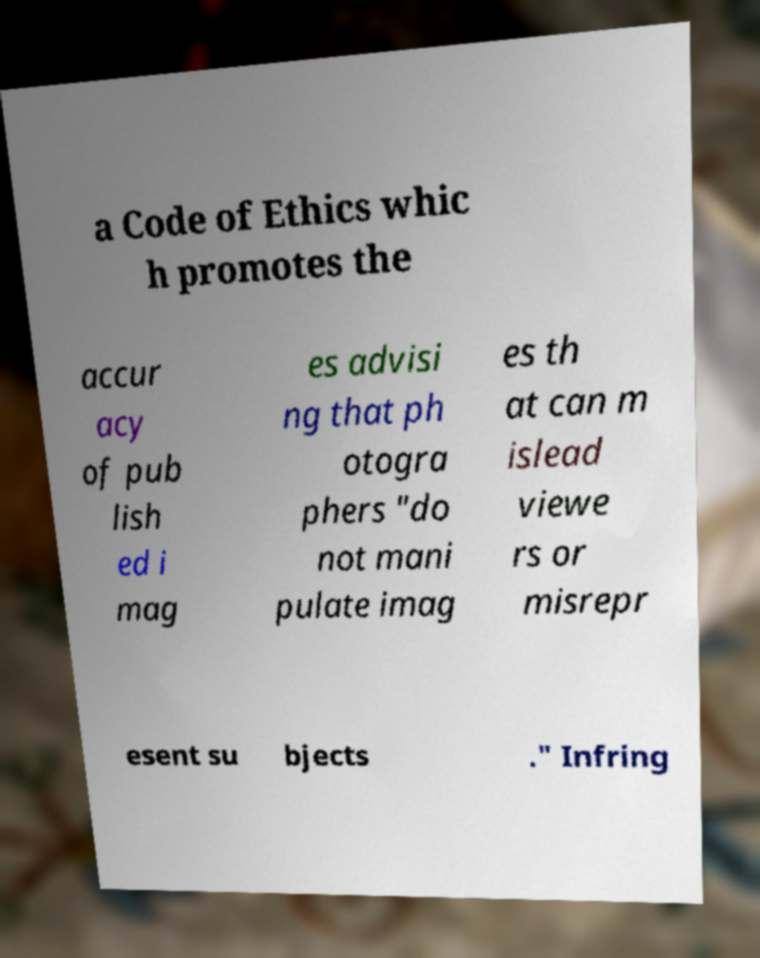What messages or text are displayed in this image? I need them in a readable, typed format. a Code of Ethics whic h promotes the accur acy of pub lish ed i mag es advisi ng that ph otogra phers "do not mani pulate imag es th at can m islead viewe rs or misrepr esent su bjects ." Infring 